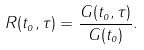Convert formula to latex. <formula><loc_0><loc_0><loc_500><loc_500>R ( t _ { o } , \tau ) = \frac { G ( t _ { o } , \tau ) } { G ( t _ { o } ) } .</formula> 